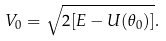<formula> <loc_0><loc_0><loc_500><loc_500>V _ { 0 } = \sqrt { 2 [ E - U ( \theta _ { 0 } ) ] } .</formula> 